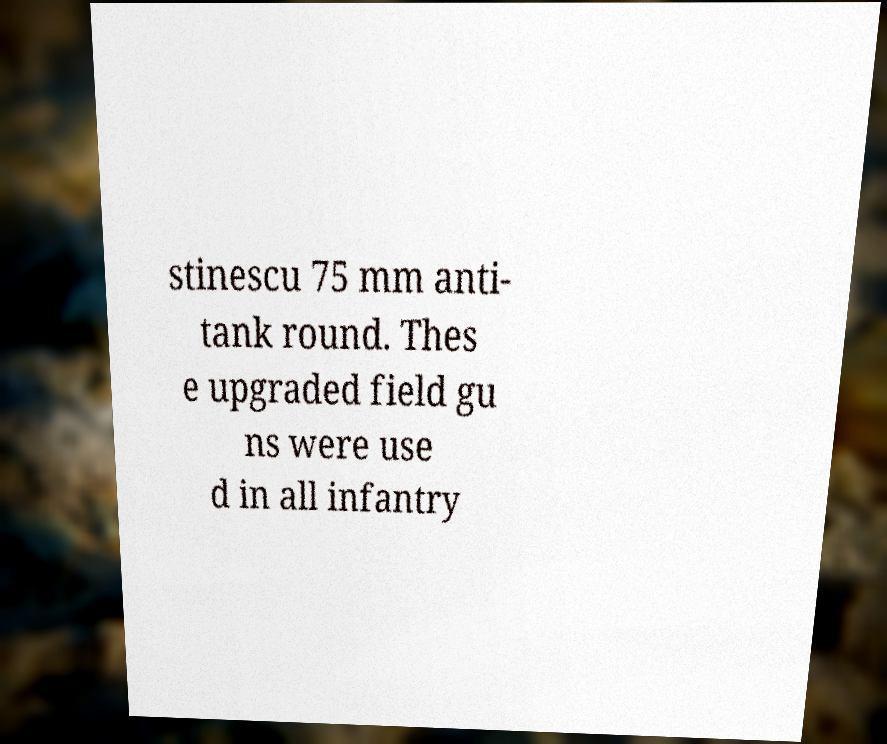Can you read and provide the text displayed in the image?This photo seems to have some interesting text. Can you extract and type it out for me? stinescu 75 mm anti- tank round. Thes e upgraded field gu ns were use d in all infantry 